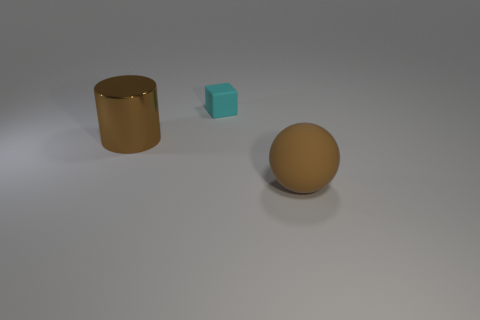Add 3 big blue things. How many objects exist? 6 Subtract all balls. How many objects are left? 2 Add 1 spheres. How many spheres are left? 2 Add 1 blue spheres. How many blue spheres exist? 1 Subtract 1 cyan cubes. How many objects are left? 2 Subtract all small cubes. Subtract all large brown blocks. How many objects are left? 2 